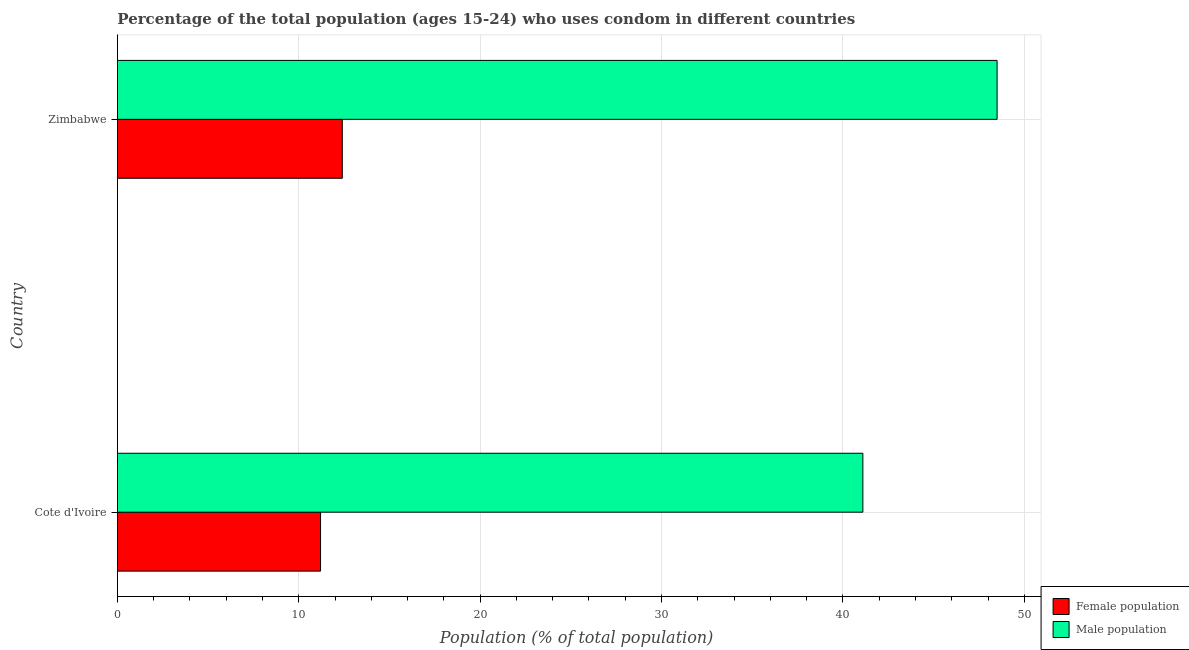How many groups of bars are there?
Provide a short and direct response. 2. Are the number of bars per tick equal to the number of legend labels?
Your response must be concise. Yes. Are the number of bars on each tick of the Y-axis equal?
Give a very brief answer. Yes. How many bars are there on the 2nd tick from the bottom?
Ensure brevity in your answer.  2. What is the label of the 1st group of bars from the top?
Make the answer very short. Zimbabwe. What is the male population in Zimbabwe?
Your answer should be very brief. 48.5. Across all countries, what is the maximum male population?
Your answer should be compact. 48.5. Across all countries, what is the minimum male population?
Provide a succinct answer. 41.1. In which country was the male population maximum?
Your answer should be compact. Zimbabwe. In which country was the male population minimum?
Provide a short and direct response. Cote d'Ivoire. What is the total male population in the graph?
Provide a short and direct response. 89.6. What is the difference between the female population in Cote d'Ivoire and that in Zimbabwe?
Your response must be concise. -1.2. What is the difference between the female population in Cote d'Ivoire and the male population in Zimbabwe?
Provide a short and direct response. -37.3. What is the average male population per country?
Give a very brief answer. 44.8. What is the difference between the female population and male population in Zimbabwe?
Provide a short and direct response. -36.1. In how many countries, is the female population greater than 22 %?
Offer a very short reply. 0. What is the ratio of the male population in Cote d'Ivoire to that in Zimbabwe?
Keep it short and to the point. 0.85. Is the female population in Cote d'Ivoire less than that in Zimbabwe?
Provide a succinct answer. Yes. What does the 1st bar from the top in Cote d'Ivoire represents?
Your answer should be compact. Male population. What does the 1st bar from the bottom in Cote d'Ivoire represents?
Provide a succinct answer. Female population. Are all the bars in the graph horizontal?
Ensure brevity in your answer.  Yes. What is the difference between two consecutive major ticks on the X-axis?
Your response must be concise. 10. Are the values on the major ticks of X-axis written in scientific E-notation?
Offer a very short reply. No. Where does the legend appear in the graph?
Offer a very short reply. Bottom right. How are the legend labels stacked?
Your response must be concise. Vertical. What is the title of the graph?
Offer a very short reply. Percentage of the total population (ages 15-24) who uses condom in different countries. Does "Official creditors" appear as one of the legend labels in the graph?
Your response must be concise. No. What is the label or title of the X-axis?
Make the answer very short. Population (% of total population) . What is the Population (% of total population)  in Female population in Cote d'Ivoire?
Provide a short and direct response. 11.2. What is the Population (% of total population)  of Male population in Cote d'Ivoire?
Ensure brevity in your answer.  41.1. What is the Population (% of total population)  of Female population in Zimbabwe?
Your response must be concise. 12.4. What is the Population (% of total population)  in Male population in Zimbabwe?
Offer a very short reply. 48.5. Across all countries, what is the maximum Population (% of total population)  in Male population?
Keep it short and to the point. 48.5. Across all countries, what is the minimum Population (% of total population)  of Male population?
Provide a short and direct response. 41.1. What is the total Population (% of total population)  of Female population in the graph?
Provide a succinct answer. 23.6. What is the total Population (% of total population)  of Male population in the graph?
Provide a short and direct response. 89.6. What is the difference between the Population (% of total population)  of Female population in Cote d'Ivoire and that in Zimbabwe?
Your response must be concise. -1.2. What is the difference between the Population (% of total population)  in Male population in Cote d'Ivoire and that in Zimbabwe?
Ensure brevity in your answer.  -7.4. What is the difference between the Population (% of total population)  of Female population in Cote d'Ivoire and the Population (% of total population)  of Male population in Zimbabwe?
Your answer should be very brief. -37.3. What is the average Population (% of total population)  in Male population per country?
Provide a short and direct response. 44.8. What is the difference between the Population (% of total population)  of Female population and Population (% of total population)  of Male population in Cote d'Ivoire?
Ensure brevity in your answer.  -29.9. What is the difference between the Population (% of total population)  of Female population and Population (% of total population)  of Male population in Zimbabwe?
Keep it short and to the point. -36.1. What is the ratio of the Population (% of total population)  of Female population in Cote d'Ivoire to that in Zimbabwe?
Provide a short and direct response. 0.9. What is the ratio of the Population (% of total population)  in Male population in Cote d'Ivoire to that in Zimbabwe?
Ensure brevity in your answer.  0.85. 